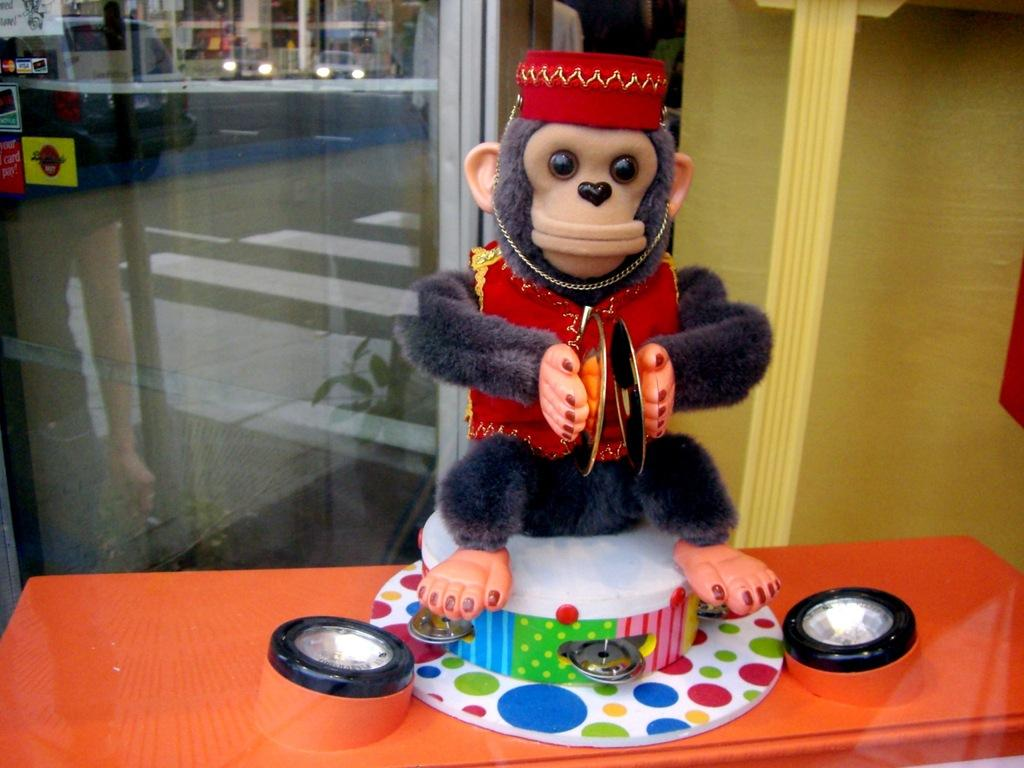What is placed on the table in the image? There is a monkey doll placed on a table. How many lights can be seen in the image? There are two lights in the image. What is visible in the background of the image? There is a group of vehicles parked on the road in the background of the image. What type of offer is the monkey doll making to the vehicles in the image? The monkey doll is not making any offers in the image; it is a stationary doll. 